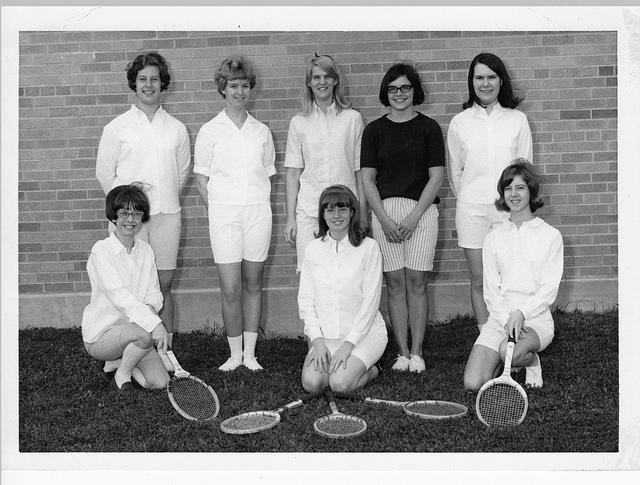How many people are there?
Give a very brief answer. 8. How many women have a dark shirt?
Give a very brief answer. 1. How many people are in the photo?
Give a very brief answer. 8. How many tennis rackets can you see?
Give a very brief answer. 2. 